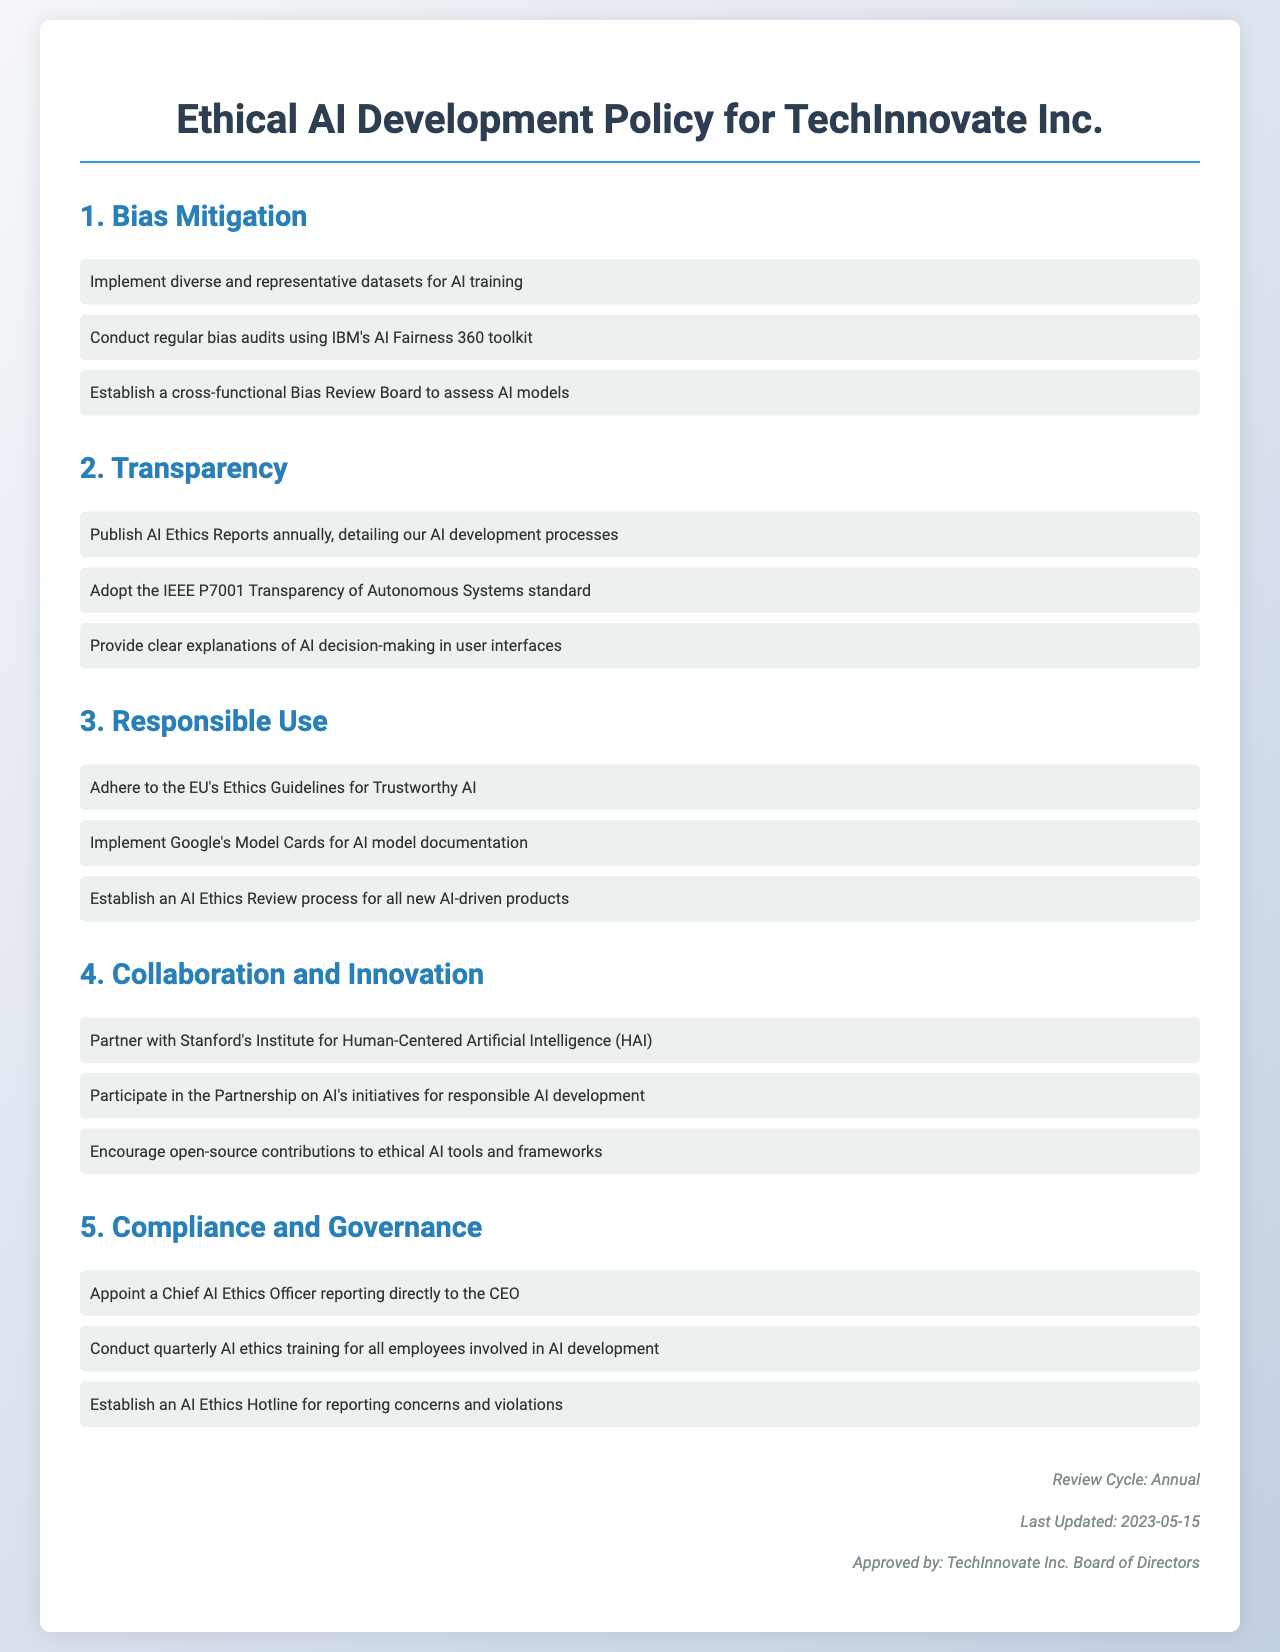What are the three main areas covered in the policy? The document outlines three main areas: Bias Mitigation, Transparency, and Responsible Use.
Answer: Bias Mitigation, Transparency, Responsible Use What organization is responsible for conducting regular bias audits? The policy mentions the use of IBM's AI Fairness 360 toolkit for conducting regular audits.
Answer: IBM How often must the AI Ethics Reports be published? The document specifies that AI Ethics Reports must be published annually.
Answer: Annually What is the role of the Chief AI Ethics Officer? The Chief AI Ethics Officer’s role is to report directly to the CEO and oversee AI ethics.
Answer: Report directly to the CEO Which standard is adopted for transparency in AI systems? The document states that the IEEE P7001 Transparency of Autonomous Systems standard is adopted.
Answer: IEEE P7001 What entity is mentioned for collaboration on responsible AI development? The document refers to partnering with Stanford's Institute for Human-Centered Artificial Intelligence (HAI).
Answer: Stanford's Institute for Human-Centered Artificial Intelligence (HAI) What tool is recommended for AI model documentation? Google's Model Cards are recommended for documentation in the policy.
Answer: Google’s Model Cards How frequently will AI ethics training occur? AI ethics training for employees involved in AI development is to be conducted quarterly.
Answer: Quarterly What is established for reporting concerns and violations? An AI Ethics Hotline is established for reporting concerns and violations.
Answer: AI Ethics Hotline 